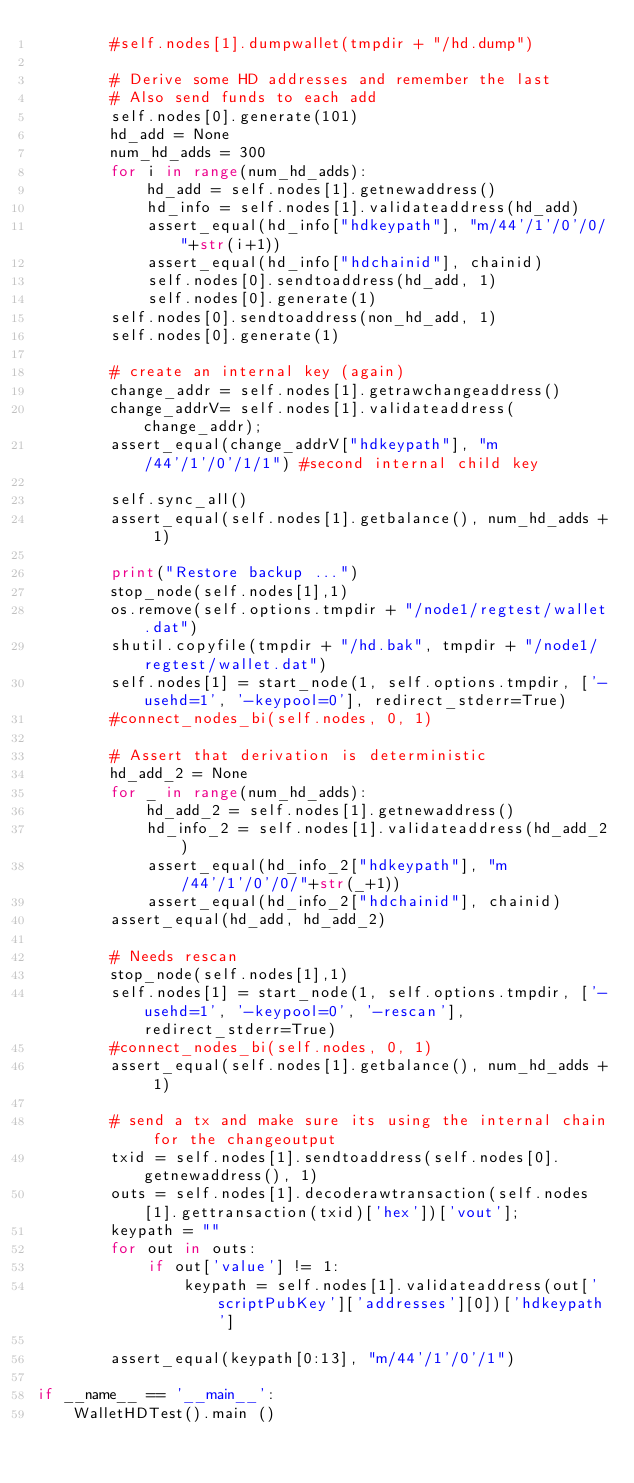Convert code to text. <code><loc_0><loc_0><loc_500><loc_500><_Python_>        #self.nodes[1].dumpwallet(tmpdir + "/hd.dump")

        # Derive some HD addresses and remember the last
        # Also send funds to each add
        self.nodes[0].generate(101)
        hd_add = None
        num_hd_adds = 300
        for i in range(num_hd_adds):
            hd_add = self.nodes[1].getnewaddress()
            hd_info = self.nodes[1].validateaddress(hd_add)
            assert_equal(hd_info["hdkeypath"], "m/44'/1'/0'/0/"+str(i+1))
            assert_equal(hd_info["hdchainid"], chainid)
            self.nodes[0].sendtoaddress(hd_add, 1)
            self.nodes[0].generate(1)
        self.nodes[0].sendtoaddress(non_hd_add, 1)
        self.nodes[0].generate(1)

        # create an internal key (again)
        change_addr = self.nodes[1].getrawchangeaddress()
        change_addrV= self.nodes[1].validateaddress(change_addr);
        assert_equal(change_addrV["hdkeypath"], "m/44'/1'/0'/1/1") #second internal child key

        self.sync_all()
        assert_equal(self.nodes[1].getbalance(), num_hd_adds + 1)

        print("Restore backup ...")
        stop_node(self.nodes[1],1)
        os.remove(self.options.tmpdir + "/node1/regtest/wallet.dat")
        shutil.copyfile(tmpdir + "/hd.bak", tmpdir + "/node1/regtest/wallet.dat")
        self.nodes[1] = start_node(1, self.options.tmpdir, ['-usehd=1', '-keypool=0'], redirect_stderr=True)
        #connect_nodes_bi(self.nodes, 0, 1)

        # Assert that derivation is deterministic
        hd_add_2 = None
        for _ in range(num_hd_adds):
            hd_add_2 = self.nodes[1].getnewaddress()
            hd_info_2 = self.nodes[1].validateaddress(hd_add_2)
            assert_equal(hd_info_2["hdkeypath"], "m/44'/1'/0'/0/"+str(_+1))
            assert_equal(hd_info_2["hdchainid"], chainid)
        assert_equal(hd_add, hd_add_2)

        # Needs rescan
        stop_node(self.nodes[1],1)
        self.nodes[1] = start_node(1, self.options.tmpdir, ['-usehd=1', '-keypool=0', '-rescan'], redirect_stderr=True)
        #connect_nodes_bi(self.nodes, 0, 1)
        assert_equal(self.nodes[1].getbalance(), num_hd_adds + 1)

        # send a tx and make sure its using the internal chain for the changeoutput
        txid = self.nodes[1].sendtoaddress(self.nodes[0].getnewaddress(), 1)
        outs = self.nodes[1].decoderawtransaction(self.nodes[1].gettransaction(txid)['hex'])['vout'];
        keypath = ""
        for out in outs:
            if out['value'] != 1:
                keypath = self.nodes[1].validateaddress(out['scriptPubKey']['addresses'][0])['hdkeypath']

        assert_equal(keypath[0:13], "m/44'/1'/0'/1")

if __name__ == '__main__':
    WalletHDTest().main ()
</code> 